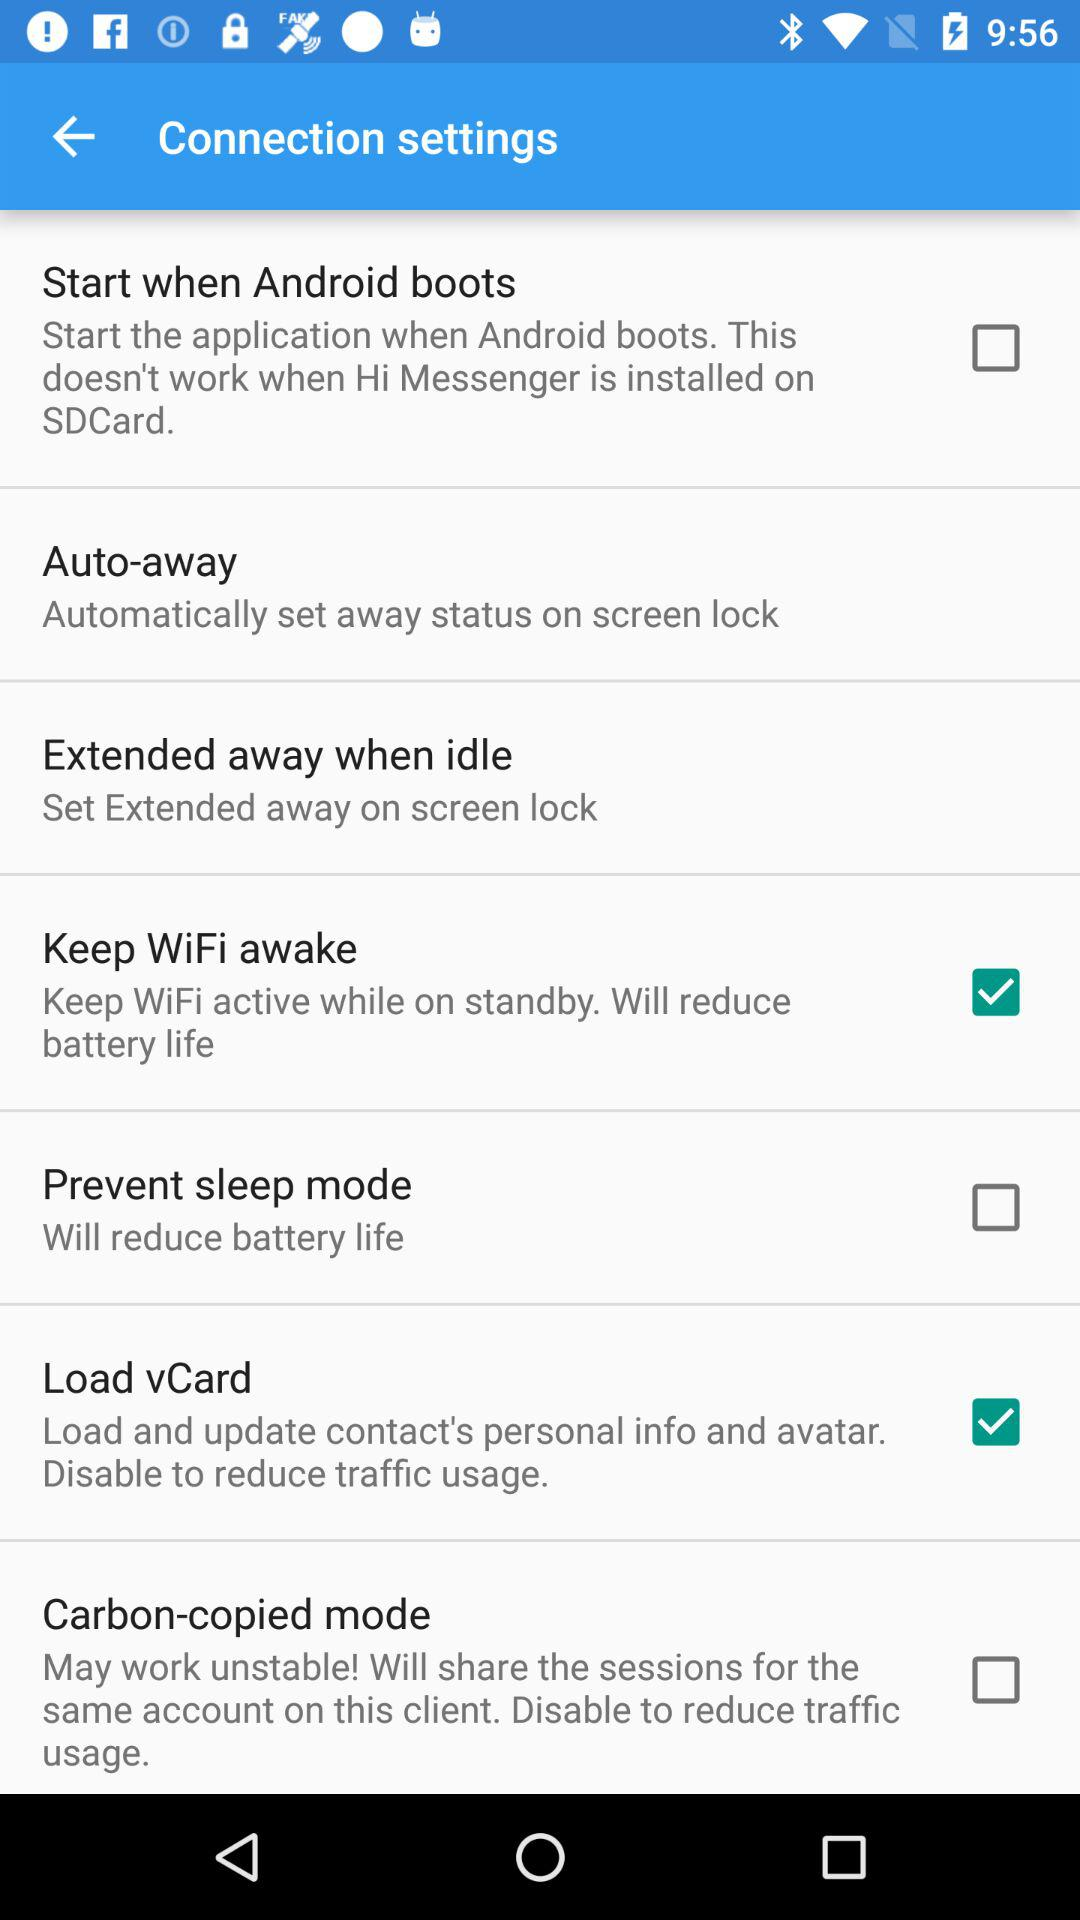What is the status of "Keep WiFi awake"? The status of "Keep WiFi awake" is "on". 